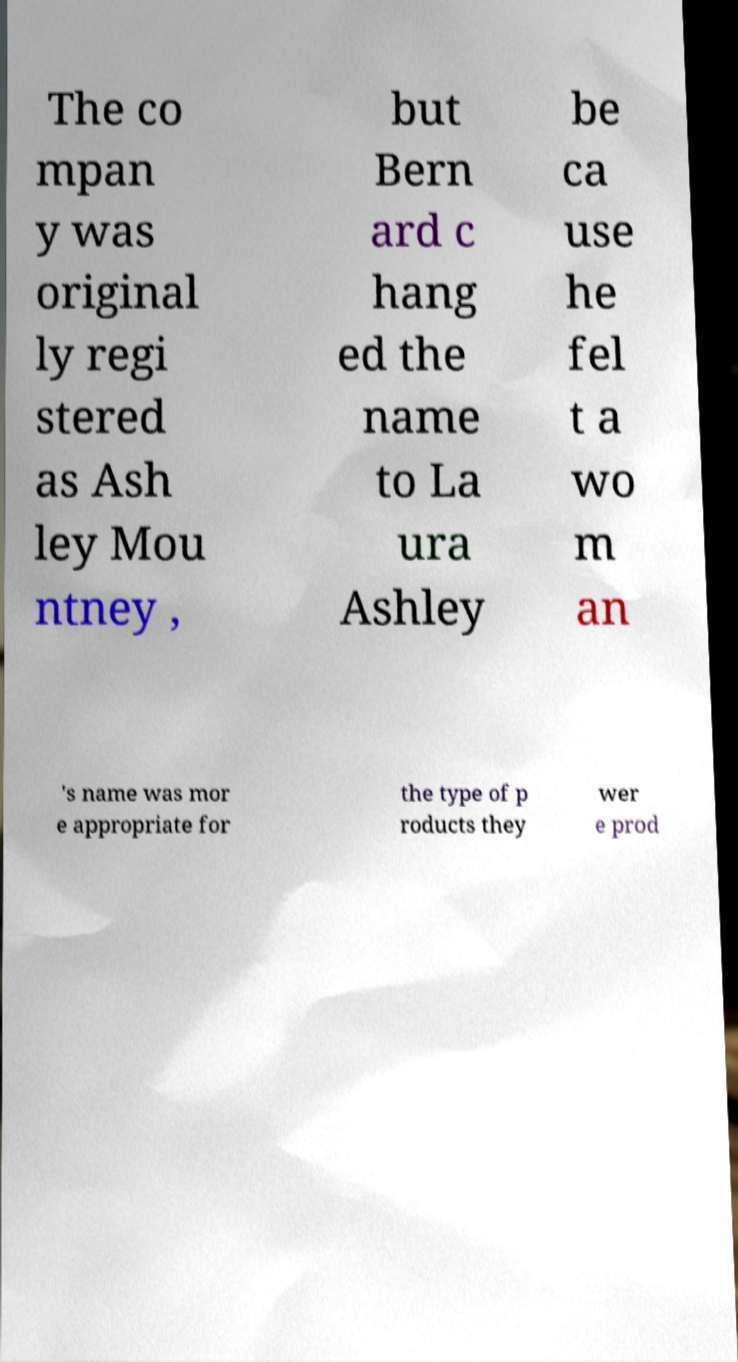What messages or text are displayed in this image? I need them in a readable, typed format. The co mpan y was original ly regi stered as Ash ley Mou ntney , but Bern ard c hang ed the name to La ura Ashley be ca use he fel t a wo m an 's name was mor e appropriate for the type of p roducts they wer e prod 